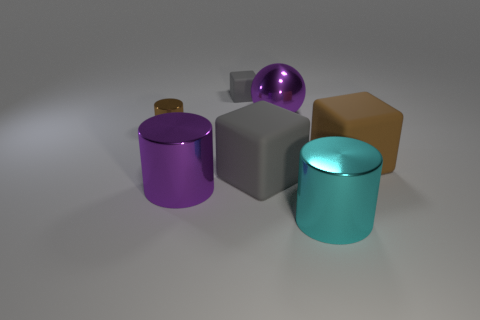Which two objects look most similar to each other in shape, and what are those shapes? The teal and purple objects share the most similar shape as they both are cylindrical. They have round bases and rise vertically with smooth, curved surfaces. Their proportions seem to be quite similar, but their colors are what set them apart visually. 